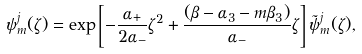Convert formula to latex. <formula><loc_0><loc_0><loc_500><loc_500>\psi ^ { j } _ { m } ( \zeta ) = \exp \left [ - \frac { \alpha _ { + } } { 2 \alpha _ { - } } { \zeta } ^ { 2 } + \frac { ( \beta - \alpha _ { 3 } - m \beta _ { 3 } ) } { \alpha _ { - } } \zeta \right ] \tilde { \psi } ^ { j } _ { m } ( \zeta ) ,</formula> 